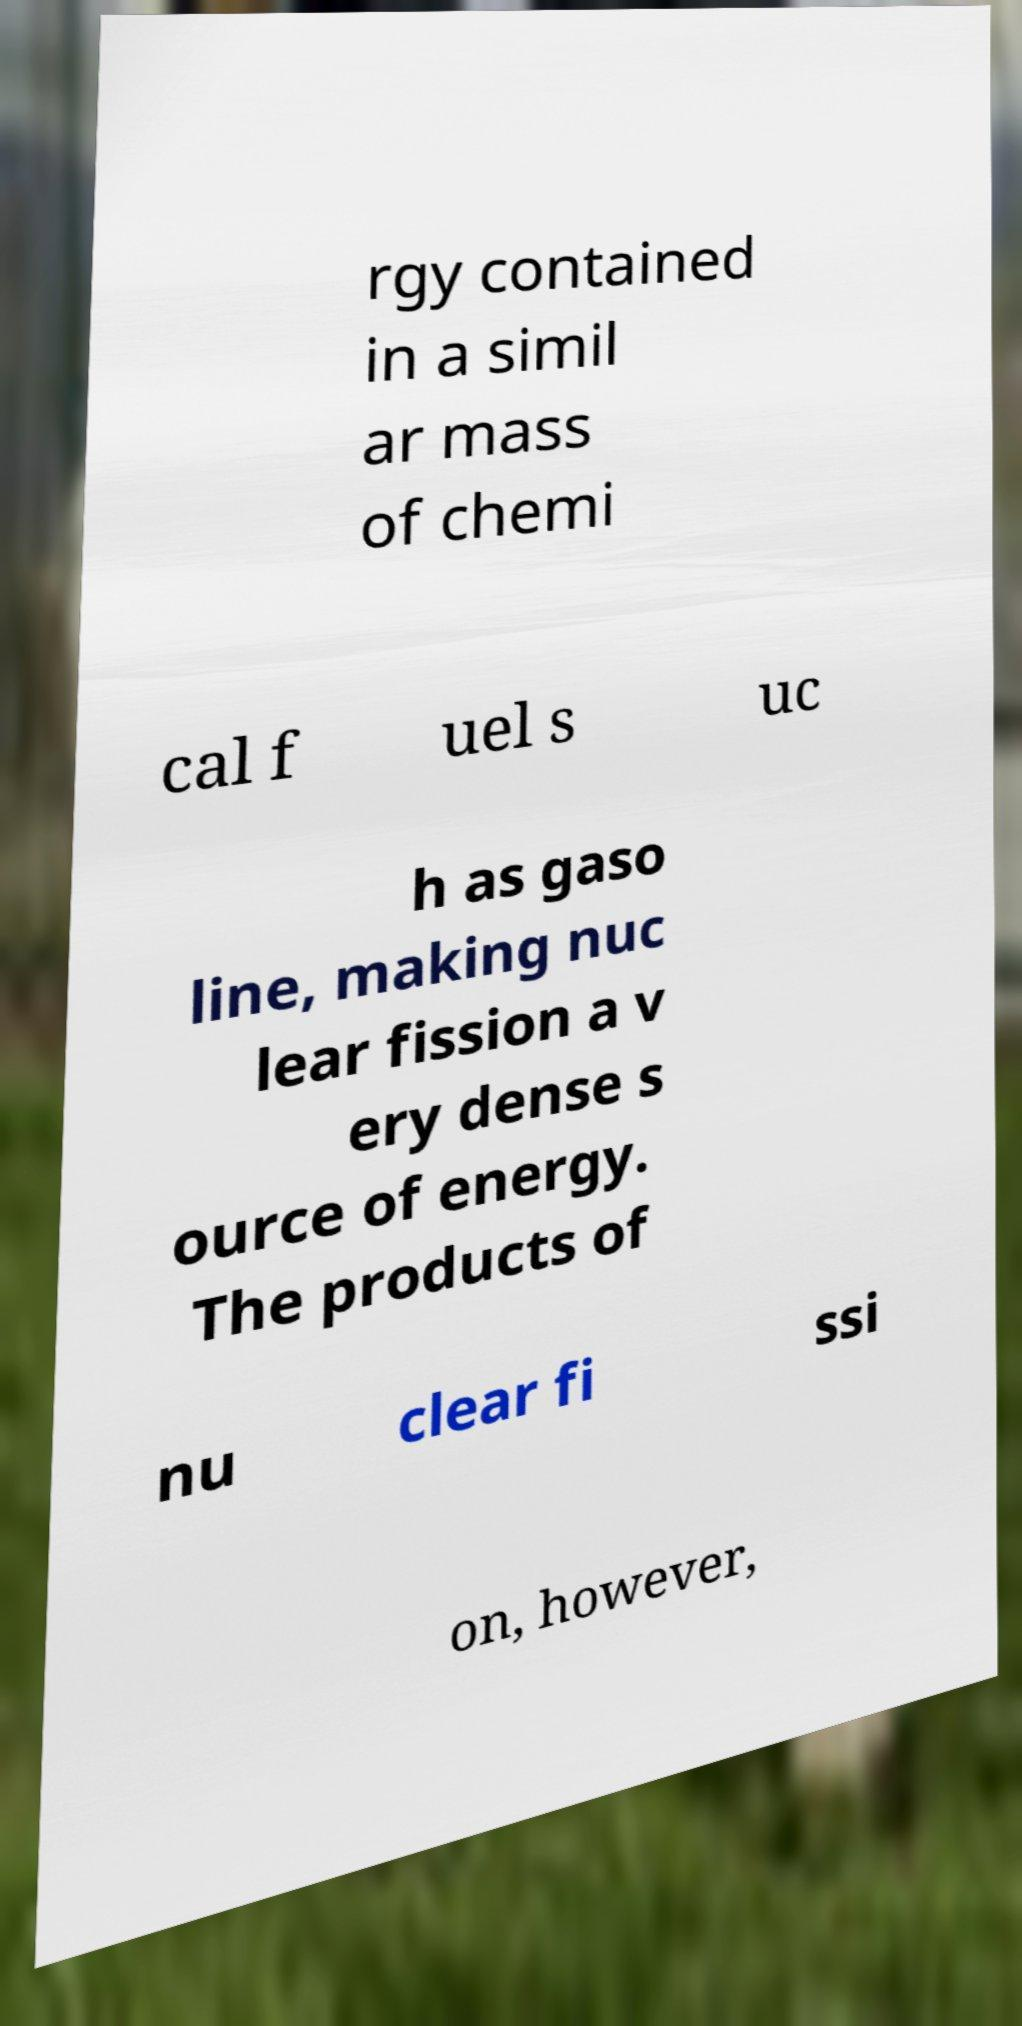I need the written content from this picture converted into text. Can you do that? rgy contained in a simil ar mass of chemi cal f uel s uc h as gaso line, making nuc lear fission a v ery dense s ource of energy. The products of nu clear fi ssi on, however, 